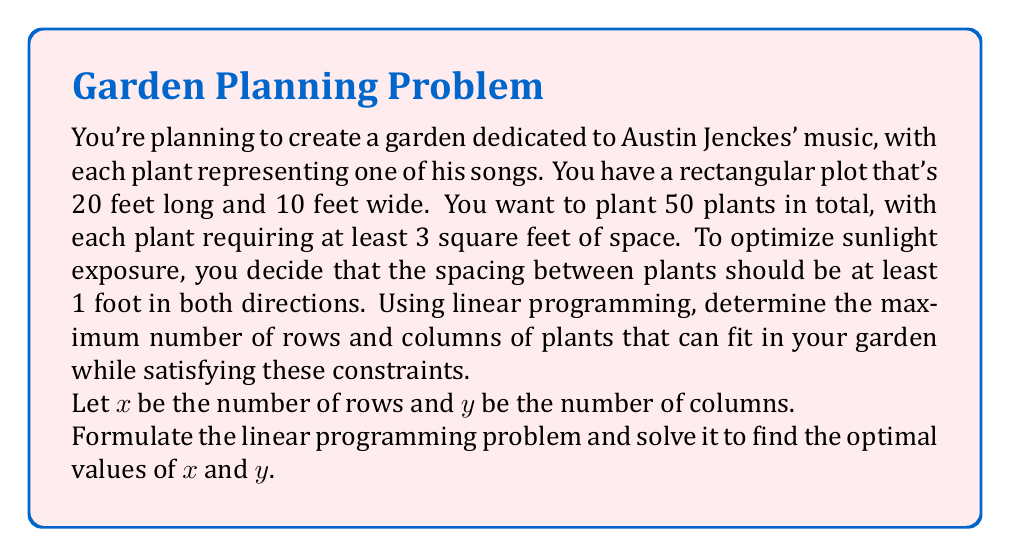Provide a solution to this math problem. Let's approach this step-by-step using linear programming:

1. Define the variables:
   $x$ = number of rows
   $y$ = number of columns

2. Objective function:
   We want to maximize the number of plants, which is $xy$.
   However, linear programming requires a linear objective function, so we'll maximize $x + y$ instead.
   
   Maximize: $z = x + y$

3. Constraints:
   a) Area constraint: Each plant needs at least 3 square feet
      $\frac{200}{xy} \geq 3$
      Simplifying: $xy \leq \frac{200}{3}$

   b) Total plants constraint:
      $xy = 50$

   c) Length constraint (including 1 foot spacing):
      $(y - 1) + y = 20$
      Simplifying: $y = 10.5$

   d) Width constraint (including 1 foot spacing):
      $(x - 1) + x = 10$
      Simplifying: $x = 5.5$

   e) Non-negativity:
      $x \geq 0, y \geq 0$

4. Solving the system:
   From constraints (c) and (d), we can see that the maximum values are:
   $x = 5$ (rounding down 5.5)
   $y = 10$ (rounding down 10.5)

   Checking the other constraints:
   - Area: $5 * 10 = 50 \leq \frac{200}{3} \approx 66.67$ (satisfied)
   - Total plants: $5 * 10 = 50$ (exactly satisfied)

5. Optimal solution:
   $x = 5$ rows
   $y = 10$ columns

This solution maximizes the number of plants while satisfying all constraints.
Answer: The optimal spacing for the garden is 5 rows and 10 columns, allowing for 50 plants with adequate spacing and area requirements. 